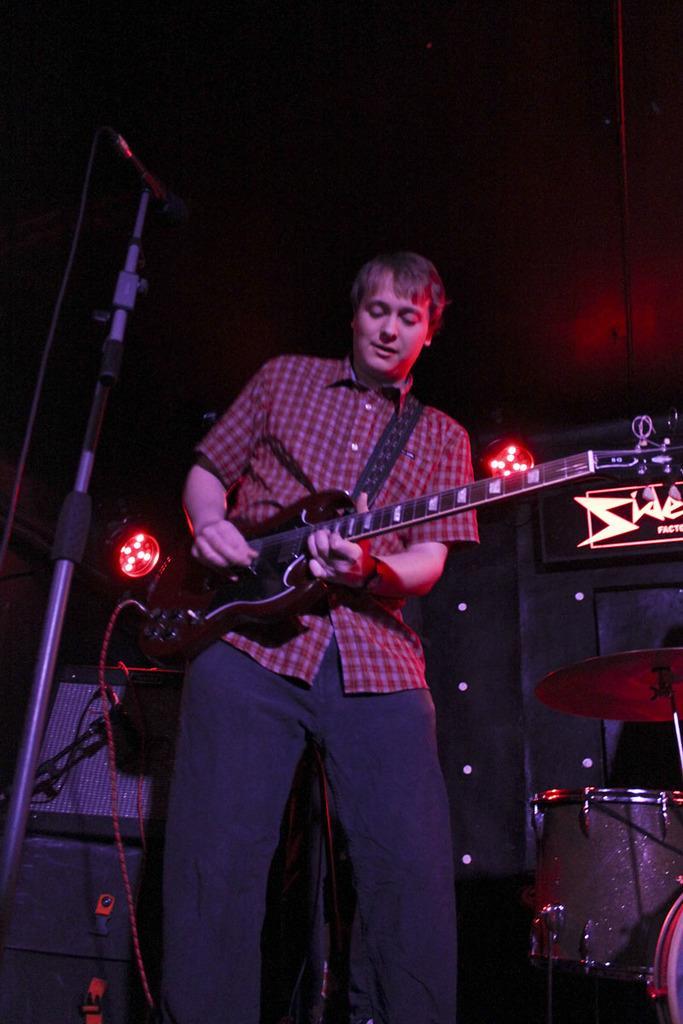In one or two sentences, can you explain what this image depicts? In the center we can see one man standing and holding guitar. And back of him we can see some musical instruments. 